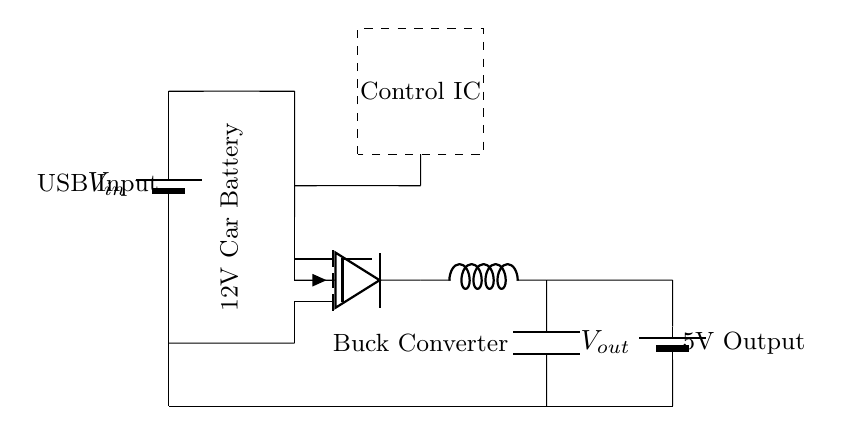What is the input voltage of this circuit? The input voltage is denoted as V sub in, which typically represents the voltage supplied from the car battery, usually about 12 volts.
Answer: 12 volts What type of converter is used in this circuit? The circuit contains a buck converter, which steps down voltage while increasing current output, highlighted by the label next to the component in the diagram.
Answer: Buck converter How many output terminals are there? The circuit shows two terminals at the output, with one labeled as V sub out and another terminal connected to the ground, indicating a total of two output points.
Answer: Two output terminals What is the output voltage of this circuit? The output voltage is indicated as V sub out, which is specified in the diagram to be 5 volts, a common output for USB car chargers.
Answer: 5 volts Which component regulates the output voltage? The component that regulates the output voltage is the control IC, shown in the dashed rectangle, which effectively manages the buck converter operation to ensure the desired output voltage.
Answer: Control IC 